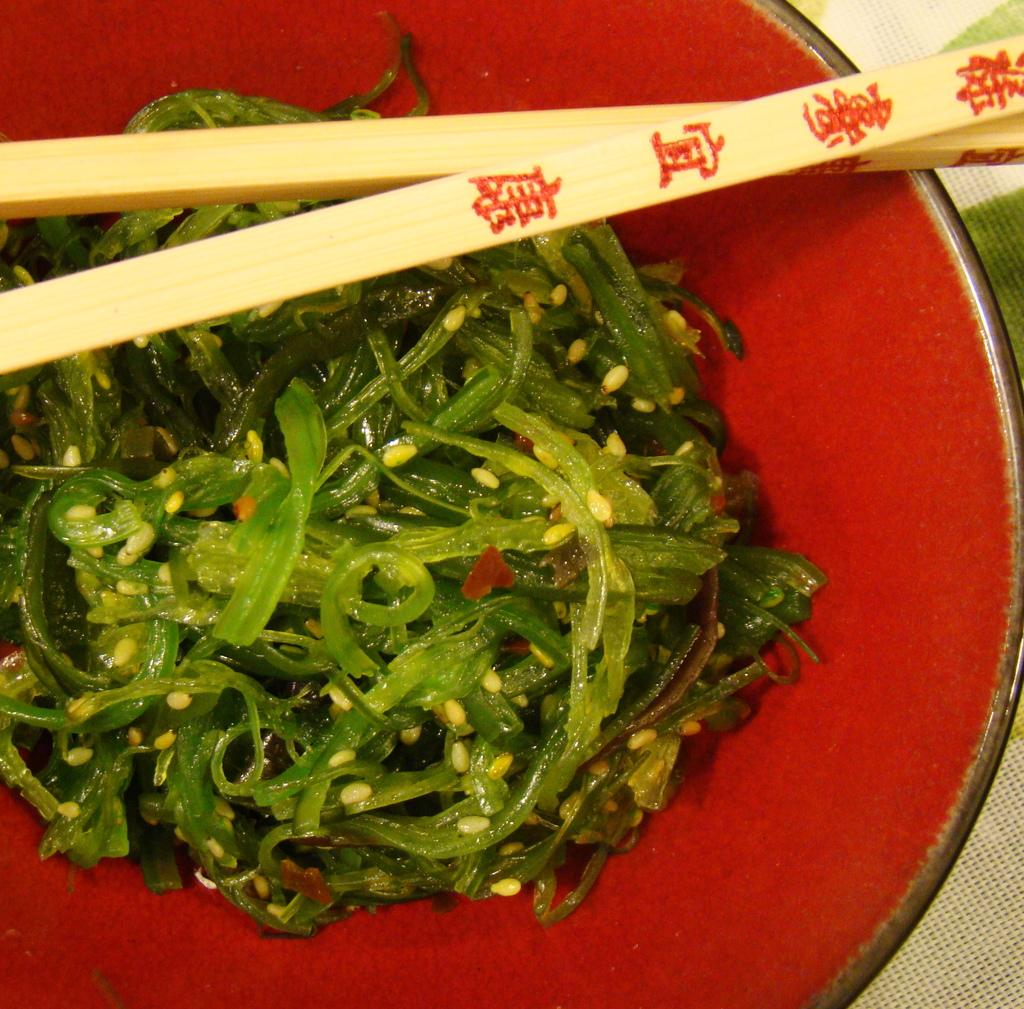What is in the bowl that is visible in the image? There is food in a bowl in the image. What utensil is present in the image? Chopsticks are present in the image. What type of juice can be seen in the image? There is no juice present in the image; it features food in a bowl and chopsticks. What is the source of power for the food in the image? The image does not depict any power source for the food; it simply shows food in a bowl and chopsticks. 